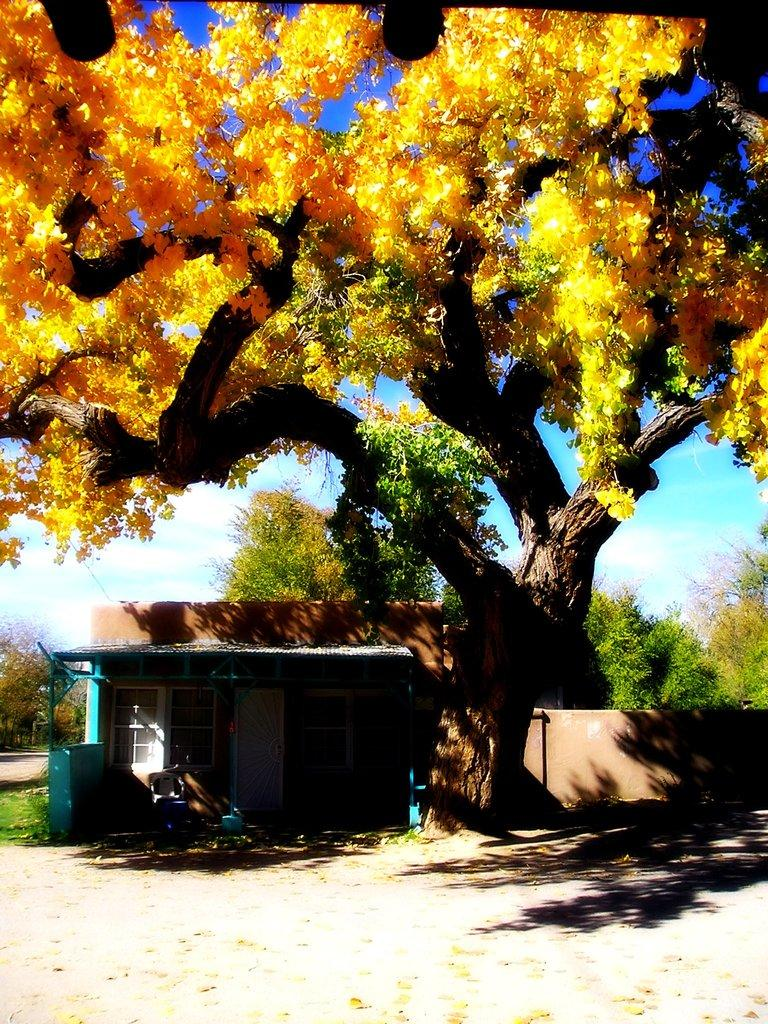What type of surface can be seen in the image? There is ground visible in the image. What type of structure is present in the image? There is a house in the image. What type of vegetation is present in the image? There are trees and grass in the image. What is visible in the background of the image? The sky is visible in the background of the image. What type of veil is draped over the trees in the image? There is no veil present in the image; the trees are not covered by any fabric or material. 